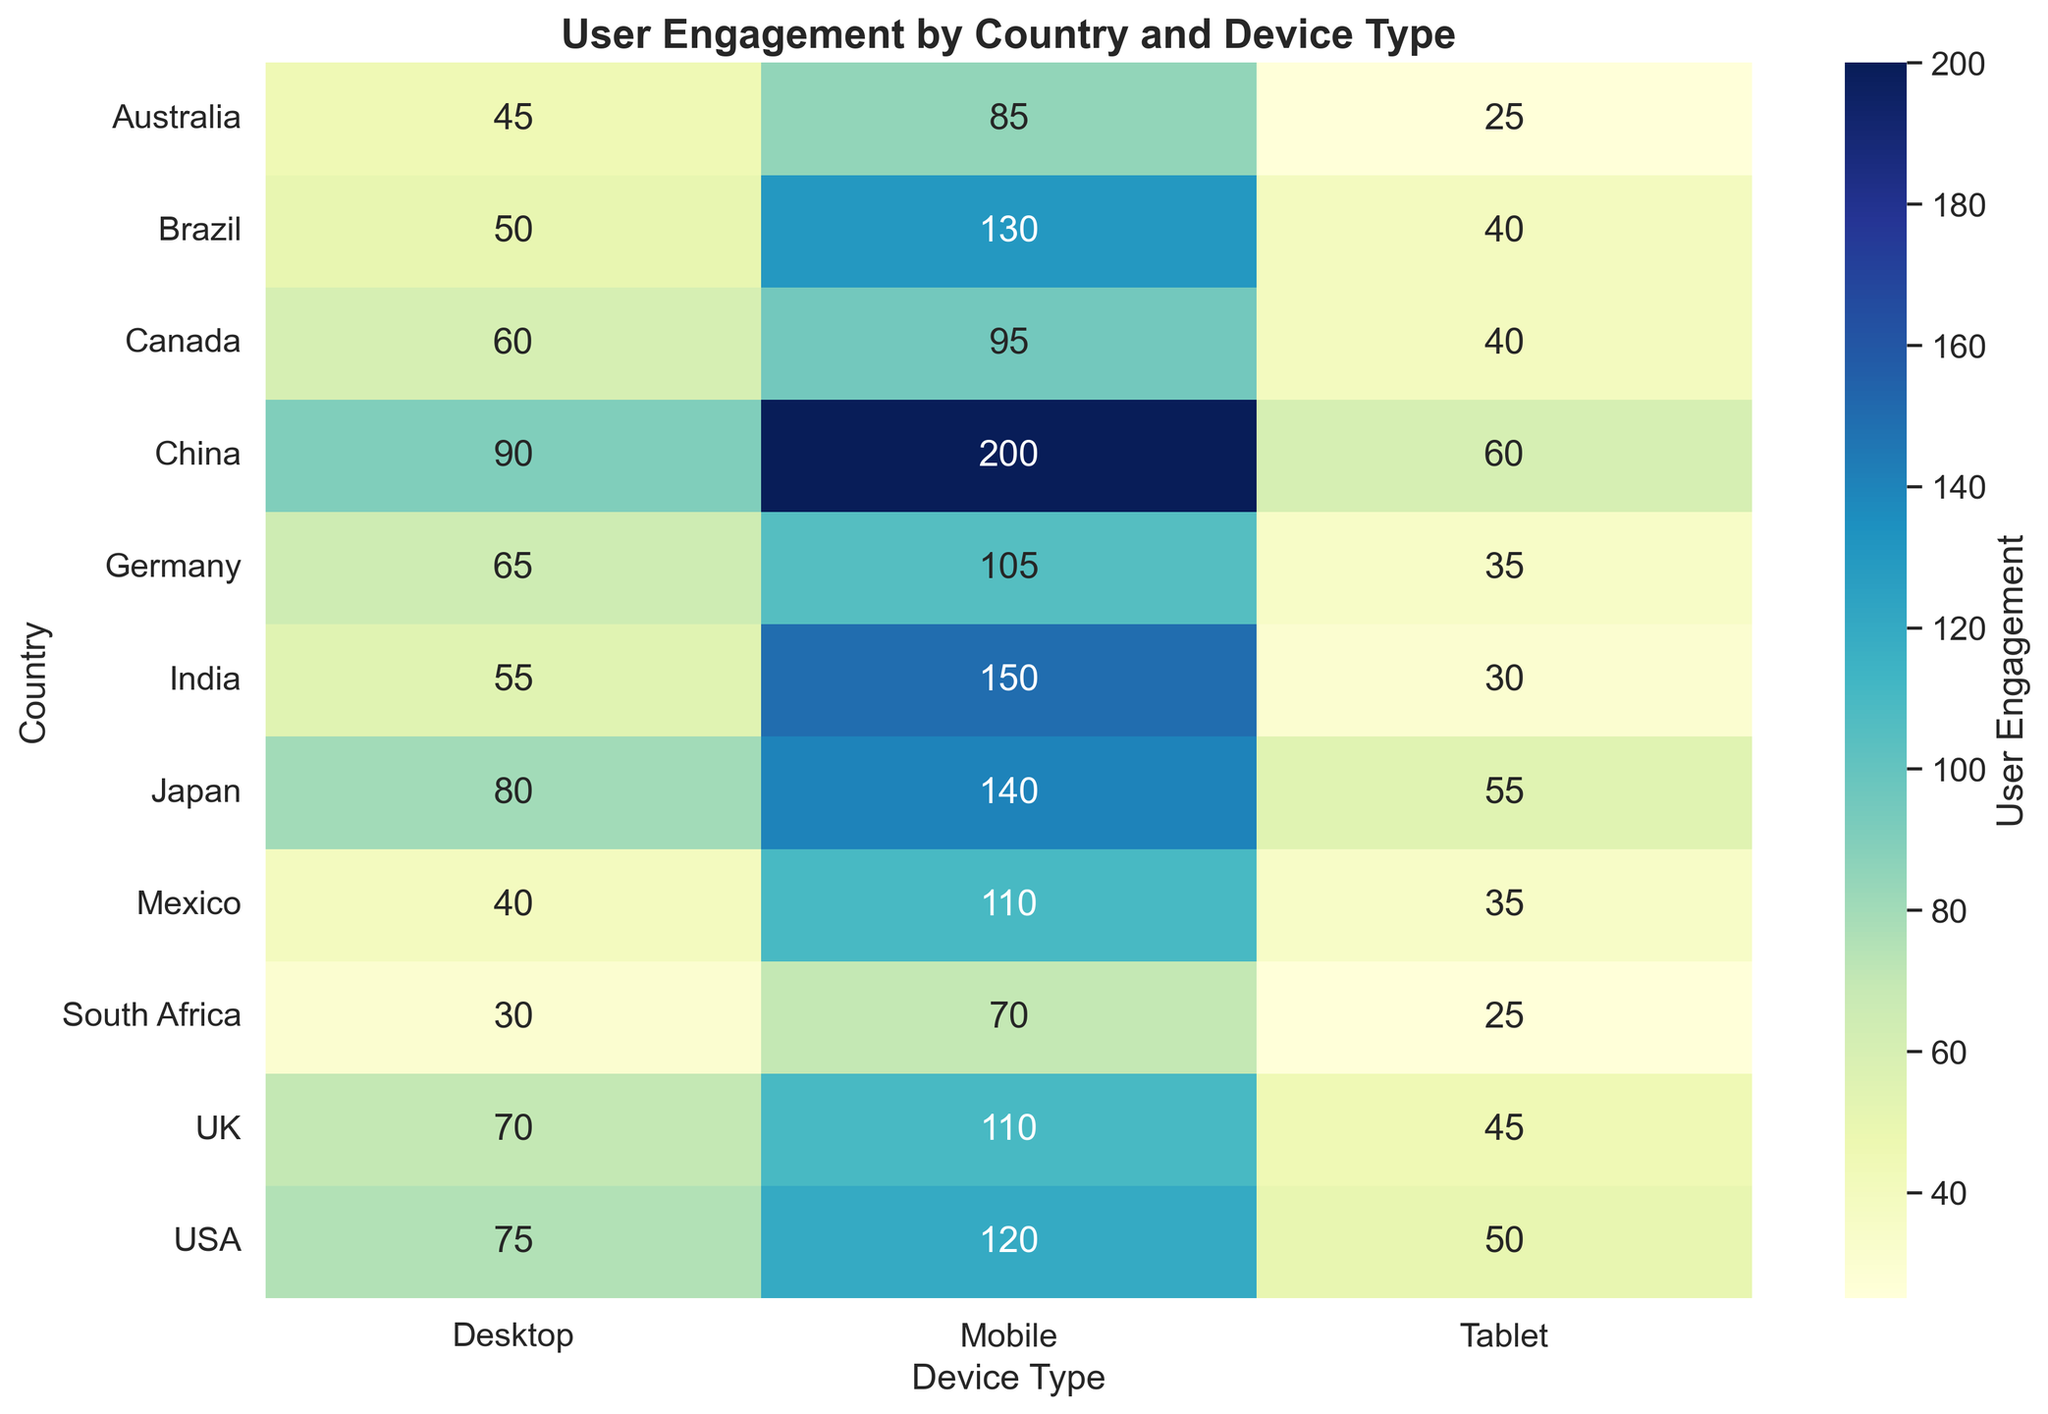Which country has the highest user engagement on mobile devices? Observing the heatmap, we look for the cell in the "Mobile" column with the highest value. China has the highest value of 200.
Answer: China Which country has the least user engagement on tablets? Observing the heatmap, we look for the cell in the "Tablet" column with the lowest value. Australia and South Africa both have the lowest value of 25.
Answer: Australia, South Africa Compare user engagement on desktop devices between the USA and Canada. Observing the heatmap, we look at the "Desktop" column under USA and Canada rows. USA has 75, and Canada has 60.
Answer: USA > Canada What's the sum of user engagement on all device types for India? Summing the values in the row for India: Desktop (55) + Mobile (150) + Tablet (30) = 235.
Answer: 235 Identify the country with the least variance in user engagement across different device types. We need to evaluate the variance across each row. South Africa has the smallest difference between its engagement values: Desktop (30), Mobile (70), Tablet (25). The variance is calculated as follows: ((70-30)^2 + (30-25)^2 + (70-25)^2) / 3 = 633.33
Answer: South Africa Which country shows more engagement on tablets than desktops? Comparing the "Tablet" and "Desktop" columns, China and Japan have more engagement on tablets (China: 60 > 90; Japan: 55 > 80).
Answer: China, Japan What's the average user engagement for mobile devices across all countries? Summing the "Mobile" column values and dividing by the number of countries. 120 + 95 + 110 + 105 + 150 + 85 + 200 + 140 + 130 + 110 + 70 = 1315; 1315 / 11 = 119.55.
Answer: 119.55 What is the most commonly occurring range of user engagement for tablets across all countries? By observing the heatmap, most values for "Tablets" fall around 25-60.
Answer: 25-60 Which country has the greatest difference in user engagement between mobile and tablet devices? We need to calculate the differences for each country. India has Desktop (55), Mobile (150), and Tablet (30). The difference for mobile and tablet is: 150 - 30 = 120.
Answer: India 